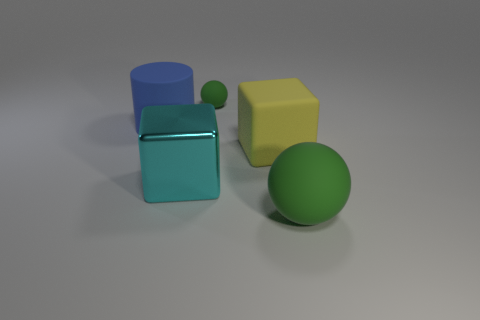Is there any other thing that has the same material as the cyan block?
Offer a very short reply. No. The green thing to the right of the green thing on the left side of the yellow rubber object is made of what material?
Make the answer very short. Rubber. How many other things are there of the same material as the big blue object?
Offer a terse response. 3. Does the large metal thing have the same shape as the small rubber object?
Offer a very short reply. No. What is the size of the green matte ball that is to the right of the tiny matte thing?
Offer a very short reply. Large. There is a yellow rubber thing; does it have the same size as the rubber sphere that is right of the tiny green sphere?
Offer a terse response. Yes. Is the number of big cyan cubes that are to the right of the yellow matte thing less than the number of yellow rubber blocks?
Your answer should be very brief. Yes. There is another big object that is the same shape as the yellow thing; what is its material?
Ensure brevity in your answer.  Metal. There is a rubber thing that is behind the big matte block and right of the cyan shiny block; what is its shape?
Offer a very short reply. Sphere. There is a big yellow thing that is made of the same material as the tiny green thing; what is its shape?
Your answer should be very brief. Cube. 